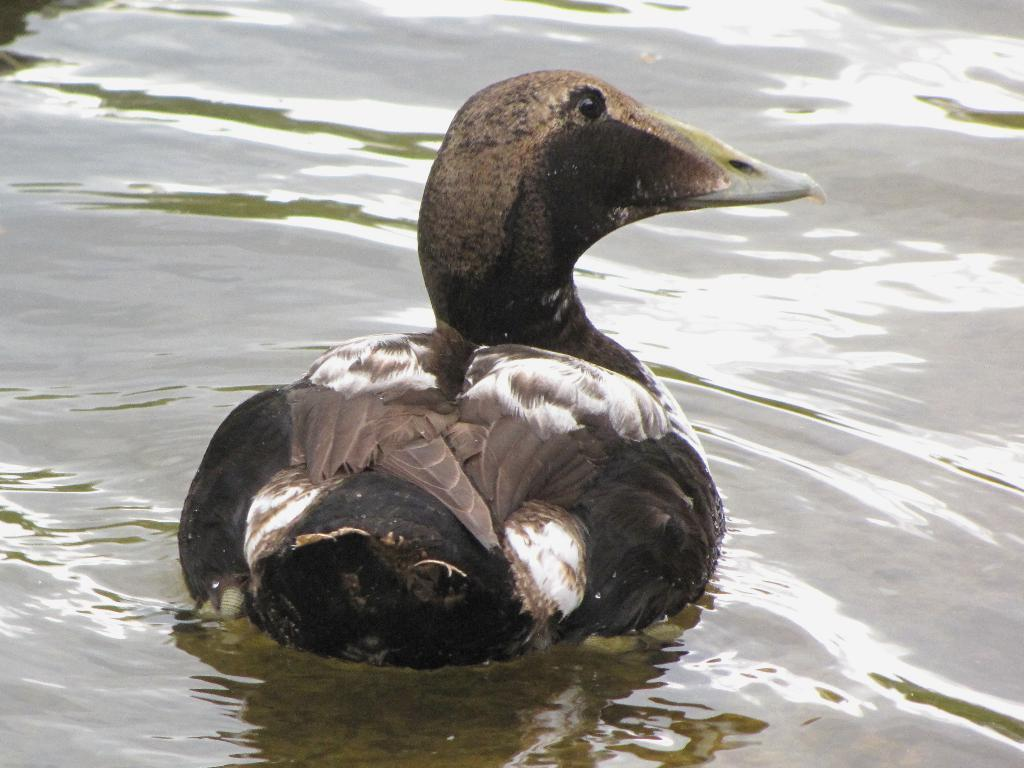What animal can be seen in the image? There is a duck in the image. What is the duck doing in the image? The duck is swimming in the water. What type of party is the duck attending in the image? There is no party present in the image, and the duck is not attending any event. 